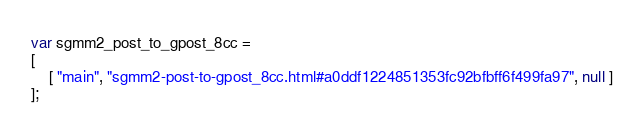<code> <loc_0><loc_0><loc_500><loc_500><_JavaScript_>var sgmm2_post_to_gpost_8cc =
[
    [ "main", "sgmm2-post-to-gpost_8cc.html#a0ddf1224851353fc92bfbff6f499fa97", null ]
];</code> 